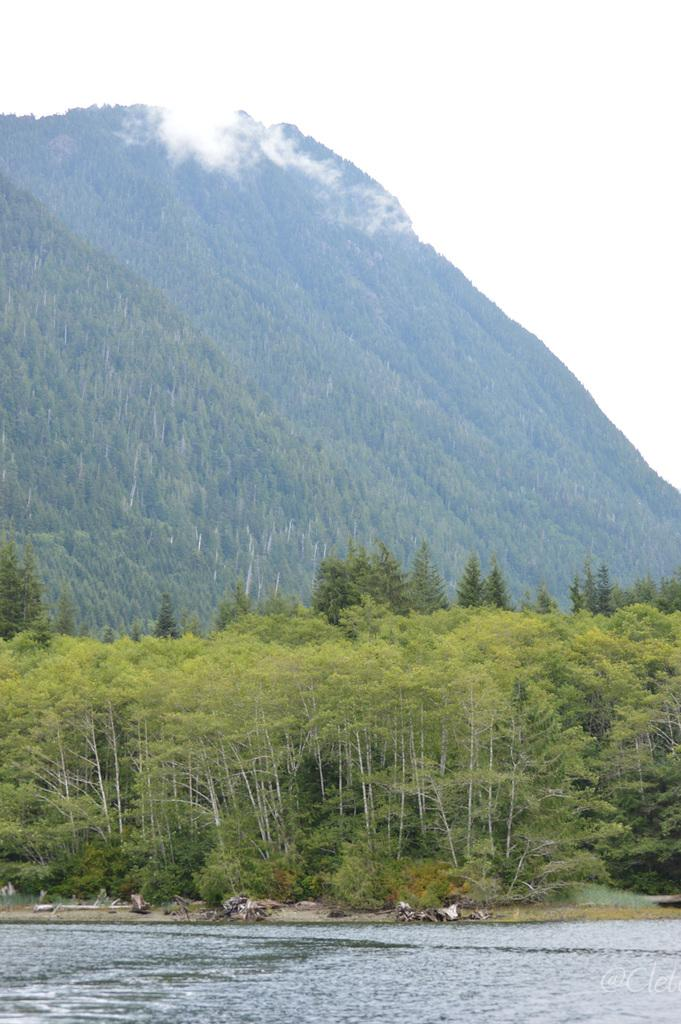What is visible in the image? Water is visible in the image. What can be seen in the background of the image? There are trees in the background of the image. What is the color of the trees? The trees are green in color. What is the color of the sky in the image? The sky is white in color. What type of dirt can be seen on the body of the person in the image? There is no person present in the image, and therefore no dirt on a body can be observed. 